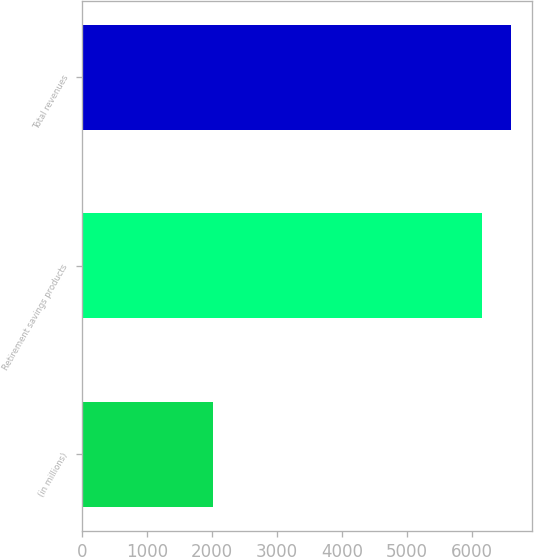<chart> <loc_0><loc_0><loc_500><loc_500><bar_chart><fcel>(in millions)<fcel>Retirement savings products<fcel>Total revenues<nl><fcel>2010<fcel>6150<fcel>6590.3<nl></chart> 